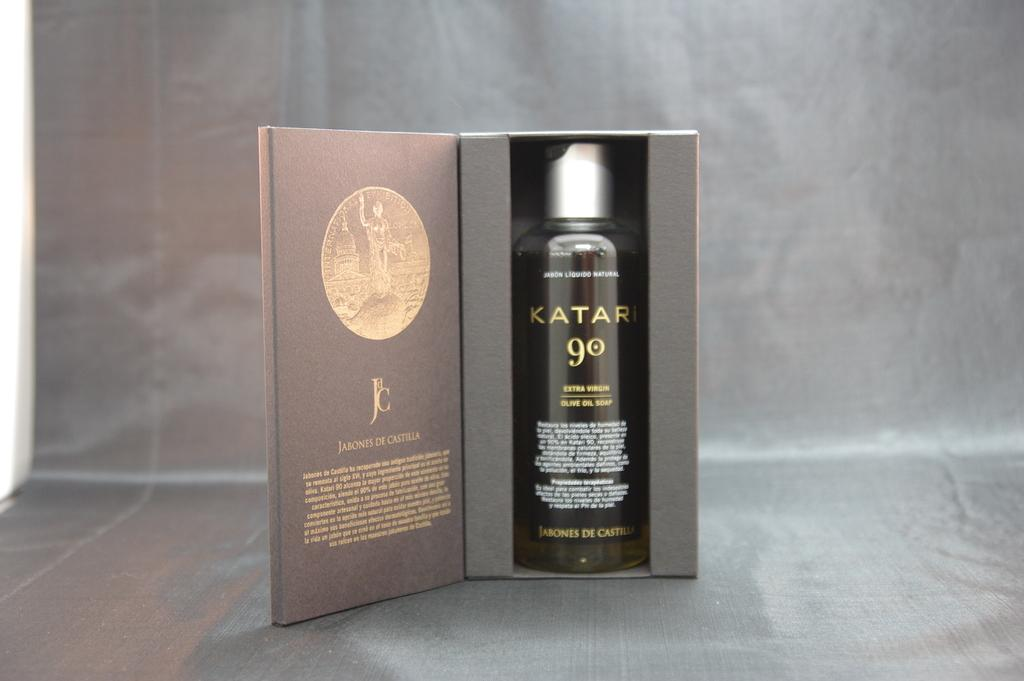<image>
Offer a succinct explanation of the picture presented. A bottle of Katari extra virgin olive oil soap. 